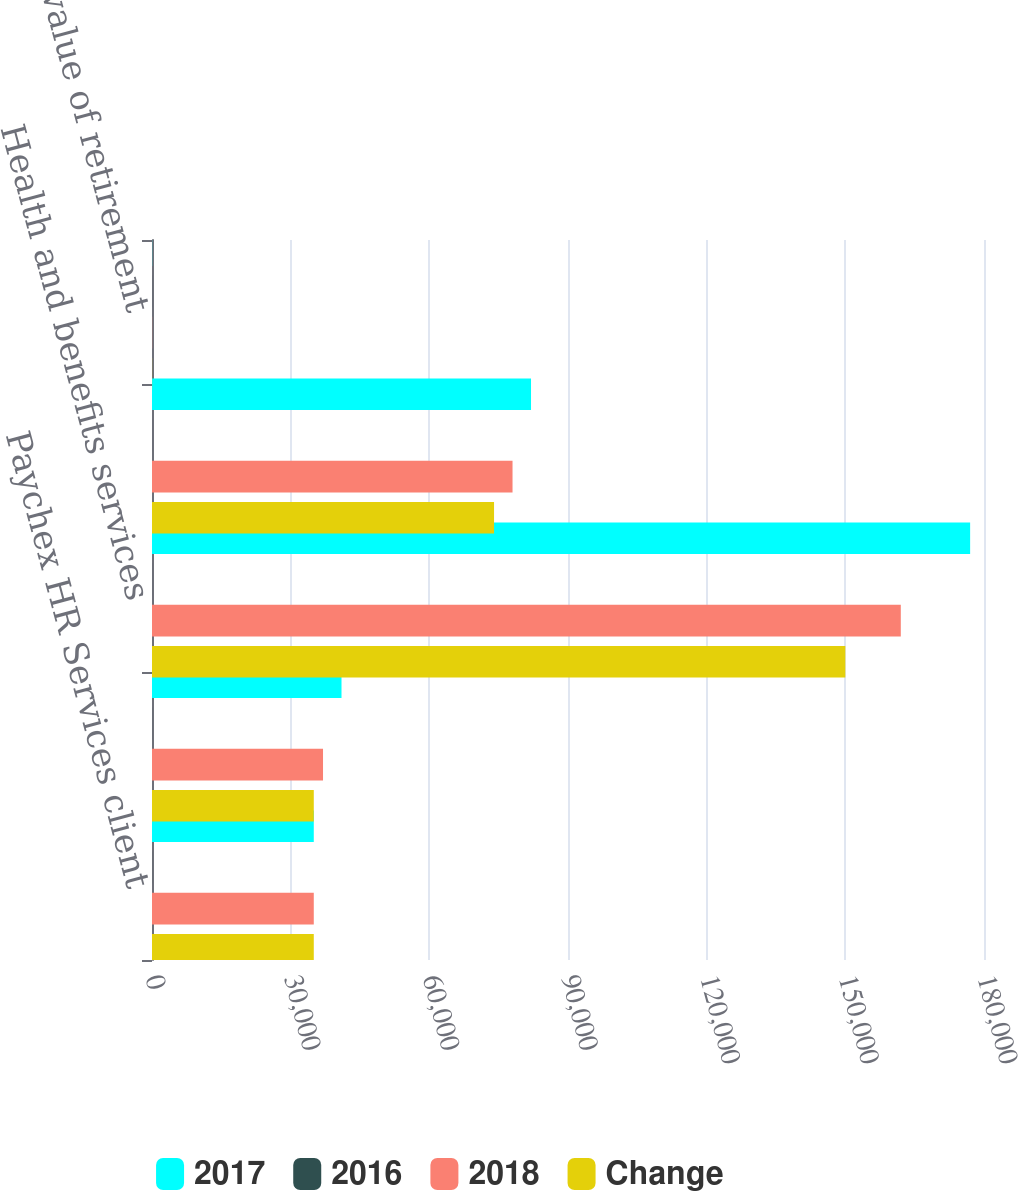Convert chart. <chart><loc_0><loc_0><loc_500><loc_500><stacked_bar_chart><ecel><fcel>Paychex HR Services client<fcel>Paychex HR Services clients<fcel>Health and benefits services<fcel>Retirement services plans<fcel>Asset value of retirement<nl><fcel>2017<fcel>35000<fcel>41000<fcel>177000<fcel>82000<fcel>30.6<nl><fcel>2016<fcel>13<fcel>12<fcel>9<fcel>6<fcel>12<nl><fcel>2018<fcel>35000<fcel>37000<fcel>162000<fcel>78000<fcel>27.4<nl><fcel>Change<fcel>35000<fcel>35000<fcel>150000<fcel>74000<fcel>23.6<nl></chart> 